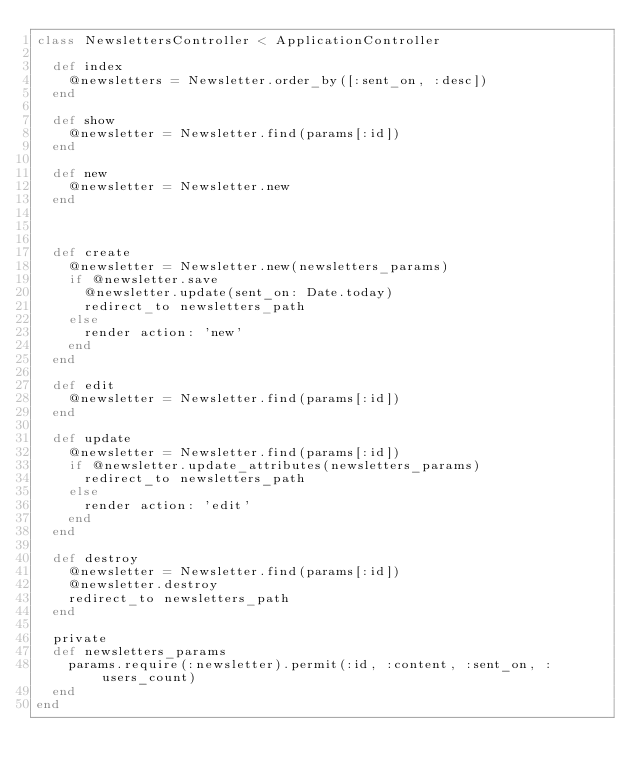<code> <loc_0><loc_0><loc_500><loc_500><_Ruby_>class NewslettersController < ApplicationController

  def index
    @newsletters = Newsletter.order_by([:sent_on, :desc])
  end

  def show
    @newsletter = Newsletter.find(params[:id])
  end

  def new 
    @newsletter = Newsletter.new
  end



  def create 
    @newsletter = Newsletter.new(newsletters_params)
    if @newsletter.save
      @newsletter.update(sent_on: Date.today)
      redirect_to newsletters_path
    else
      render action: 'new'
    end
  end

  def edit
    @newsletter = Newsletter.find(params[:id])
  end

  def update
    @newsletter = Newsletter.find(params[:id])
    if @newsletter.update_attributes(newsletters_params)
      redirect_to newsletters_path
    else
      render action: 'edit'
    end
  end

  def destroy
    @newsletter = Newsletter.find(params[:id])
    @newsletter.destroy
    redirect_to newsletters_path
  end

  private
  def newsletters_params
    params.require(:newsletter).permit(:id, :content, :sent_on, :users_count)
  end
end
</code> 